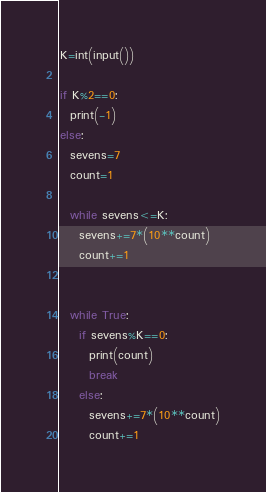Convert code to text. <code><loc_0><loc_0><loc_500><loc_500><_Python_>K=int(input())
 
if K%2==0:
  print(-1)
else:
  sevens=7
  count=1
  
  while sevens<=K:
    sevens+=7*(10**count)
    count+=1
    
  
  while True:
    if sevens%K==0:
      print(count)
      break
    else:
      sevens+=7*(10**count)
      count+=1
</code> 